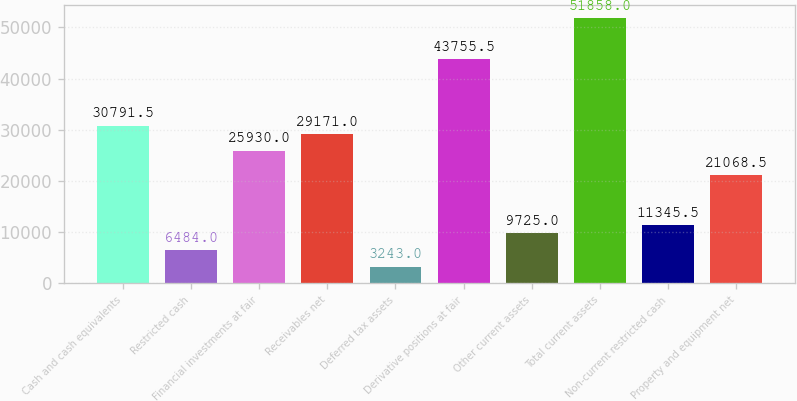Convert chart to OTSL. <chart><loc_0><loc_0><loc_500><loc_500><bar_chart><fcel>Cash and cash equivalents<fcel>Restricted cash<fcel>Financial investments at fair<fcel>Receivables net<fcel>Deferred tax assets<fcel>Derivative positions at fair<fcel>Other current assets<fcel>Total current assets<fcel>Non-current restricted cash<fcel>Property and equipment net<nl><fcel>30791.5<fcel>6484<fcel>25930<fcel>29171<fcel>3243<fcel>43755.5<fcel>9725<fcel>51858<fcel>11345.5<fcel>21068.5<nl></chart> 